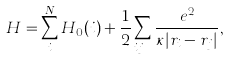<formula> <loc_0><loc_0><loc_500><loc_500>H = \sum _ { i } ^ { N } H _ { 0 } ( i ) + \frac { 1 } { 2 } \sum _ { i \neq j } \frac { e ^ { 2 } } { \kappa | r _ { i } - r _ { j } | } ,</formula> 